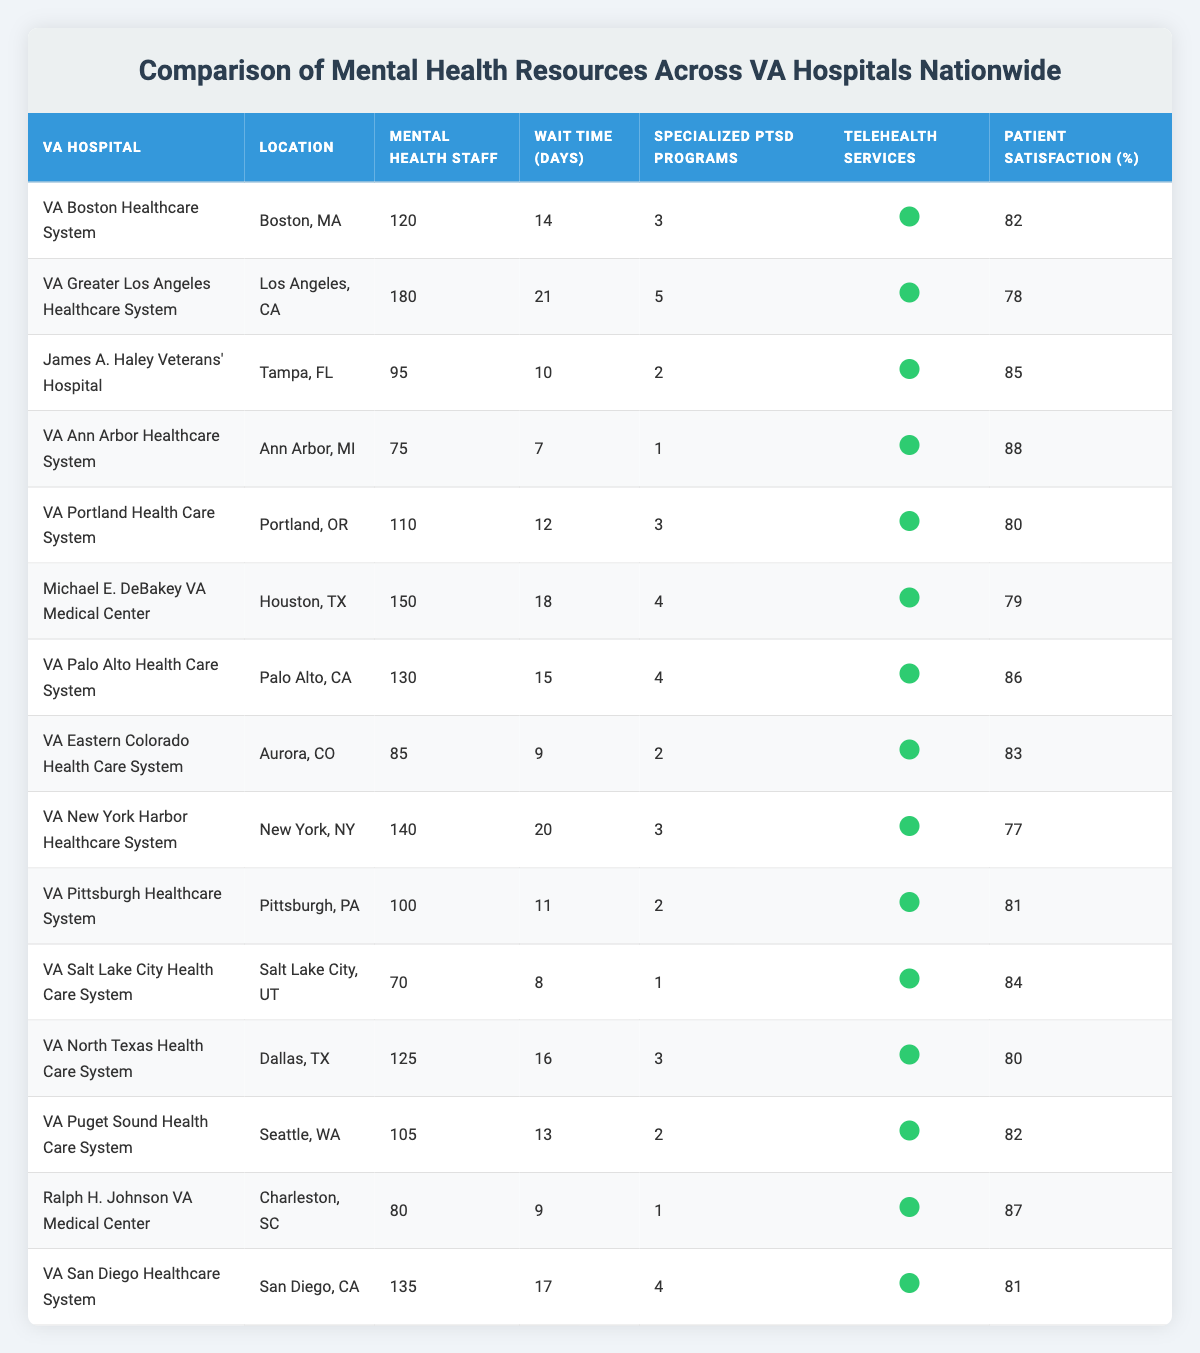What is the location of the VA hospital with the highest number of mental health staff? The table lists the number of mental health staff for each VA hospital. The VA Greater Los Angeles Healthcare System has the highest number, with 180 staff members, located in Los Angeles, CA.
Answer: Los Angeles, CA What is the average wait time for mental health services across the VA hospitals? To find the average wait time, we add up all the wait times: (14 + 21 + 10 + 7 + 12 + 18 + 15 + 9 + 20 + 11 + 8 + 16 + 13 + 9 + 17) =  200. There are 15 hospitals, so the average wait time is 200 / 15 = 13.33 days.
Answer: 13.33 How many VA hospitals have specialized PTSD programs? The table indicates that all entries have a specified number of specialized PTSD programs. Each hospital shows a number greater than or equal to zero in that column, indicating that each hospital offers specialized PTSD programs.
Answer: 15 Which VA hospital has the highest patient satisfaction percentage? By examining the "Patient Satisfaction (%)" column, we see that James A. Haley Veterans' Hospital has a satisfaction rate of 85%, which is the highest among the listed hospitals.
Answer: James A. Haley Veterans' Hospital Is there any VA hospital with more than 180 mental health staff? The table indicates that the VA Greater Los Angeles Healthcare System has 180 staff, and no other hospital exceeds this number. Thus, there are no hospitals with more than 180 mental health staff.
Answer: No Which two hospitals have the lowest patient satisfaction, and what are their percentages? From the "Patient Satisfaction (%)" column, VA Greater Los Angeles Healthcare System has 78%, and VA New York Harbor Healthcare System has 77%. Therefore, these are the two hospitals with the lowest satisfaction rates.
Answer: 78% and 77% What is the difference in wait times between the hospital with the shortest and longest wait times? The shortest wait time is 7 days (VA Ann Arbor Healthcare System), and the longest wait time is 21 days (VA Greater Los Angeles Healthcare System). The difference is 21 - 7 = 14 days.
Answer: 14 days How many VA hospitals provide telehealth services? The table shows that all listed hospitals have telehealth services available, indicated by the 'true' value in their respective column.
Answer: 15 What is the median number of mental health staff across the VA hospitals? To find the median, we first list the number of mental health staff in ascending order: [70, 75, 80, 85, 95, 100, 105, 110, 120, 125, 130, 135, 150, 180]. There are 15 data points, so the median is the 8th value, which is 110.
Answer: 110 Are there any hospitals with wait times shorter than 10 days? By checking the "Wait Time (Days)" column, we see that both VA Ann Arbor Healthcare System (7 days) and VA Eastern Colorado Health Care System (9 days) have wait times shorter than 10 days.
Answer: Yes 